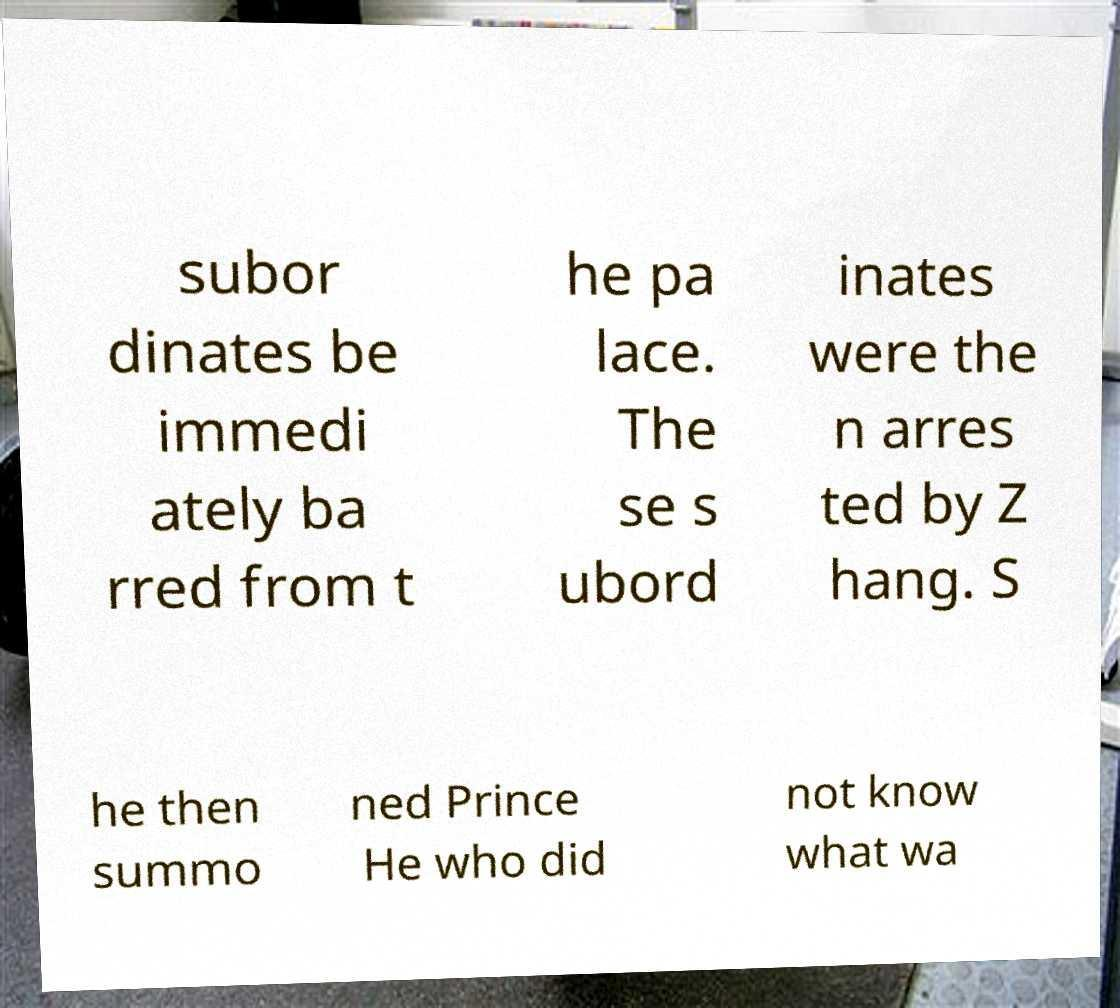Please read and relay the text visible in this image. What does it say? subor dinates be immedi ately ba rred from t he pa lace. The se s ubord inates were the n arres ted by Z hang. S he then summo ned Prince He who did not know what wa 